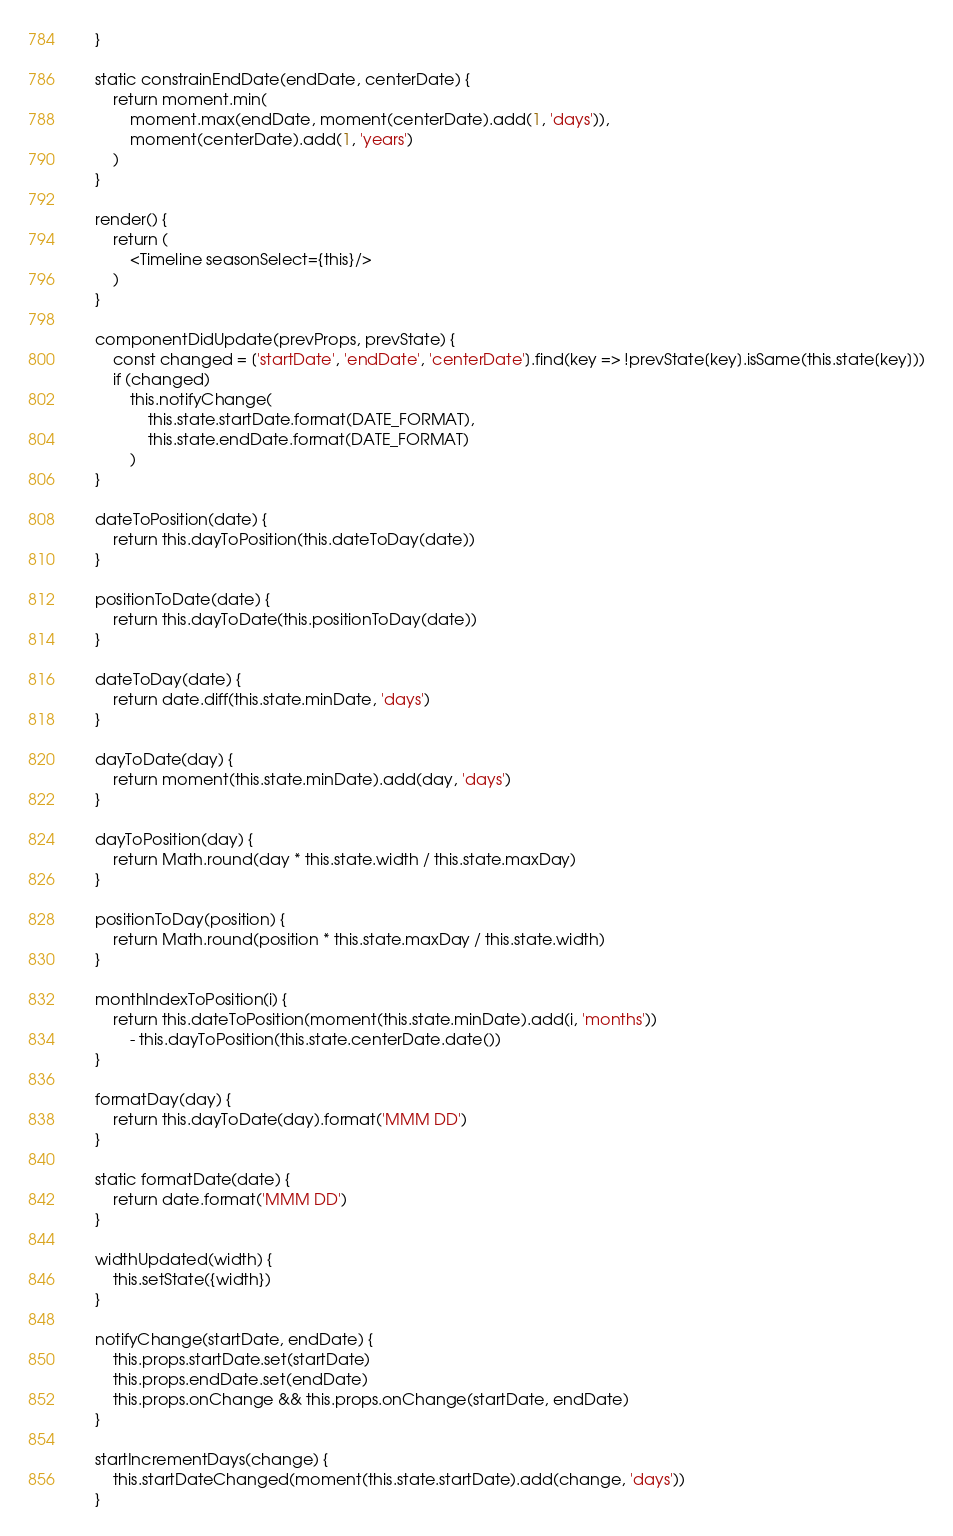Convert code to text. <code><loc_0><loc_0><loc_500><loc_500><_JavaScript_>    }

    static constrainEndDate(endDate, centerDate) {
        return moment.min(
            moment.max(endDate, moment(centerDate).add(1, 'days')),
            moment(centerDate).add(1, 'years')
        )
    }

    render() {
        return (
            <Timeline seasonSelect={this}/>
        )
    }

    componentDidUpdate(prevProps, prevState) {
        const changed = ['startDate', 'endDate', 'centerDate'].find(key => !prevState[key].isSame(this.state[key]))
        if (changed)
            this.notifyChange(
                this.state.startDate.format(DATE_FORMAT),
                this.state.endDate.format(DATE_FORMAT)
            )
    }

    dateToPosition(date) {
        return this.dayToPosition(this.dateToDay(date))
    }

    positionToDate(date) {
        return this.dayToDate(this.positionToDay(date))
    }

    dateToDay(date) {
        return date.diff(this.state.minDate, 'days')
    }

    dayToDate(day) {
        return moment(this.state.minDate).add(day, 'days')
    }

    dayToPosition(day) {
        return Math.round(day * this.state.width / this.state.maxDay)
    }

    positionToDay(position) {
        return Math.round(position * this.state.maxDay / this.state.width)
    }

    monthIndexToPosition(i) {
        return this.dateToPosition(moment(this.state.minDate).add(i, 'months'))
            - this.dayToPosition(this.state.centerDate.date())
    }

    formatDay(day) {
        return this.dayToDate(day).format('MMM DD')
    }

    static formatDate(date) {
        return date.format('MMM DD')
    }

    widthUpdated(width) {
        this.setState({width})
    }

    notifyChange(startDate, endDate) {
        this.props.startDate.set(startDate)
        this.props.endDate.set(endDate)
        this.props.onChange && this.props.onChange(startDate, endDate)
    }

    startIncrementDays(change) {
        this.startDateChanged(moment(this.state.startDate).add(change, 'days'))
    }
</code> 